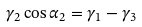<formula> <loc_0><loc_0><loc_500><loc_500>\gamma _ { 2 } \cos { \alpha _ { 2 } } = \gamma _ { 1 } - \gamma _ { 3 }</formula> 